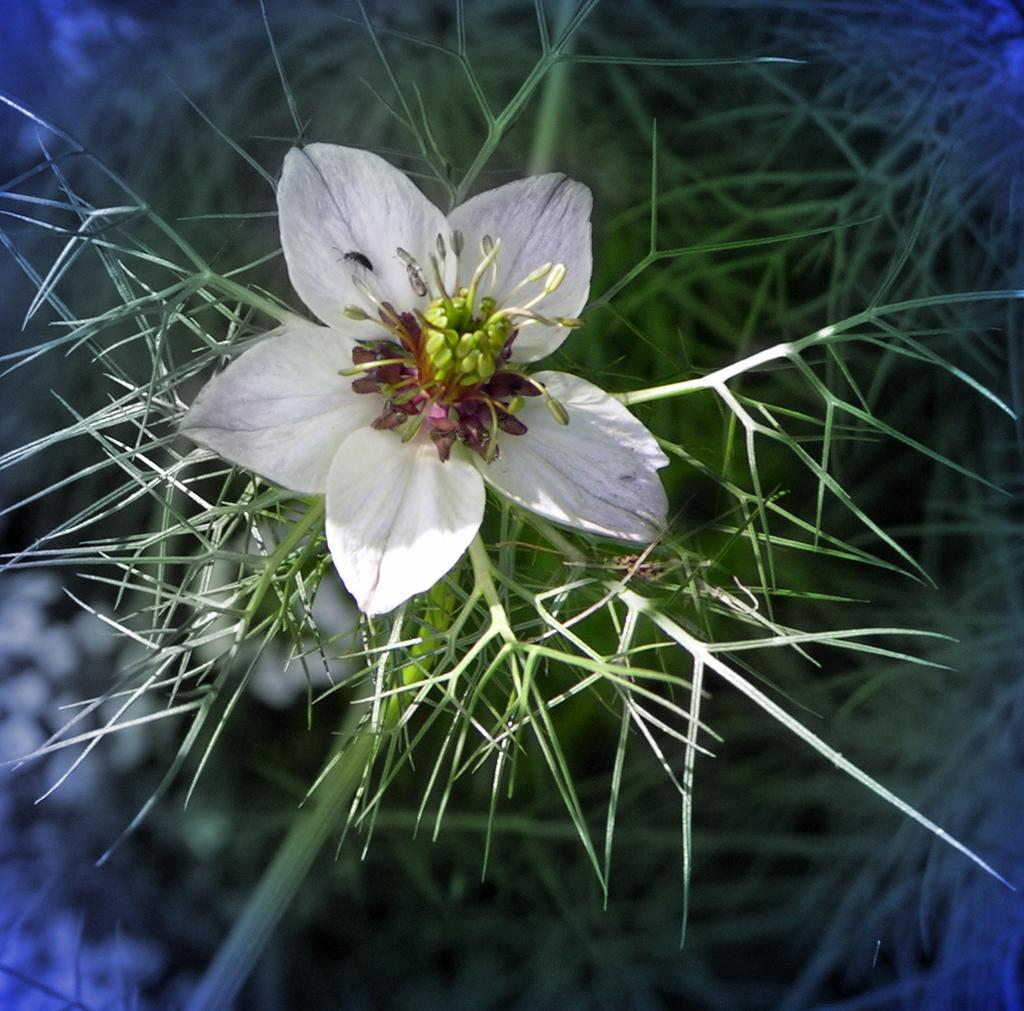What is the main subject in the foreground of the image? There is a flower in the foreground of the image. Can you describe the flower's origin or source? The flower belongs to a plant. What type of feather can be seen on the tray in the image? There is no tray or feather present in the image; it only features a flower in the foreground. 